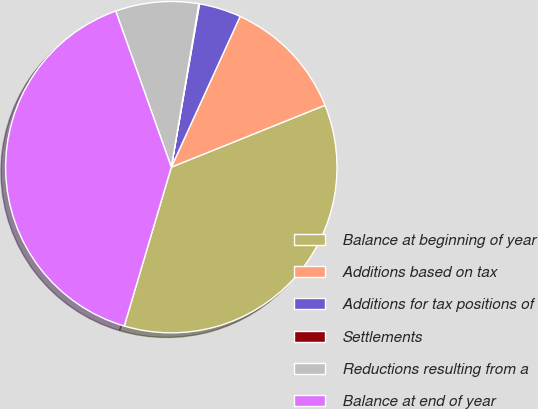Convert chart. <chart><loc_0><loc_0><loc_500><loc_500><pie_chart><fcel>Balance at beginning of year<fcel>Additions based on tax<fcel>Additions for tax positions of<fcel>Settlements<fcel>Reductions resulting from a<fcel>Balance at end of year<nl><fcel>35.68%<fcel>12.09%<fcel>4.09%<fcel>0.07%<fcel>8.1%<fcel>39.97%<nl></chart> 